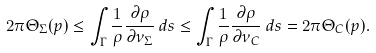<formula> <loc_0><loc_0><loc_500><loc_500>2 \pi \Theta _ { \Sigma } ( p ) \leq \int _ { \Gamma } \frac { 1 } { \rho } \frac { \partial \rho } { \partial \nu _ { \Sigma } } \, d s \leq \int _ { \Gamma } \frac { 1 } { \rho } \frac { \partial \rho } { \partial \nu _ { C } } \, d s = 2 \pi \Theta _ { C } ( p ) .</formula> 